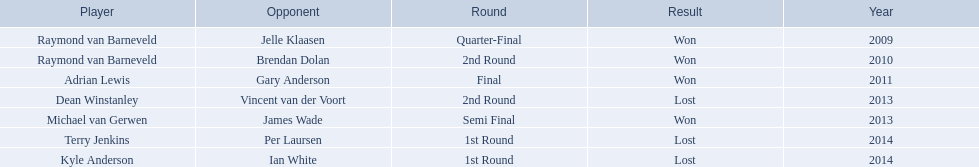Who were all the players? Raymond van Barneveld, Raymond van Barneveld, Adrian Lewis, Dean Winstanley, Michael van Gerwen, Terry Jenkins, Kyle Anderson. Which of these played in 2014? Terry Jenkins, Kyle Anderson. Who were their opponents? Per Laursen, Ian White. Which of these beat terry jenkins? Per Laursen. 